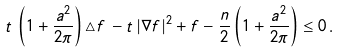<formula> <loc_0><loc_0><loc_500><loc_500>t \, \left ( 1 + \frac { a ^ { 2 } } { 2 \pi } \right ) \triangle f \, - t \, | \nabla f | ^ { 2 } + f - \frac { n } { 2 } \left ( 1 + \frac { a ^ { 2 } } { 2 \pi } \right ) \leq 0 \, .</formula> 